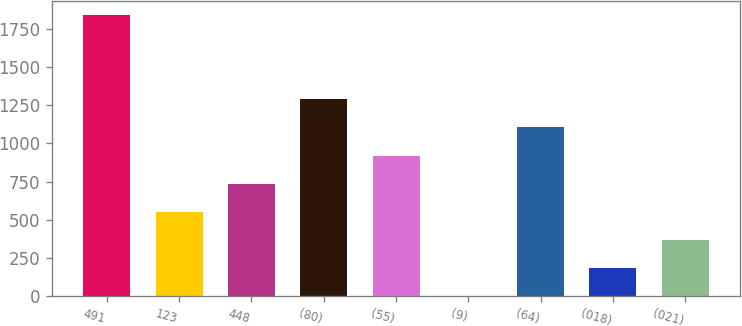<chart> <loc_0><loc_0><loc_500><loc_500><bar_chart><fcel>491<fcel>123<fcel>448<fcel>(80)<fcel>(55)<fcel>(9)<fcel>(64)<fcel>(018)<fcel>(021)<nl><fcel>1839<fcel>553.1<fcel>736.8<fcel>1287.9<fcel>920.5<fcel>2<fcel>1104.2<fcel>185.7<fcel>369.4<nl></chart> 